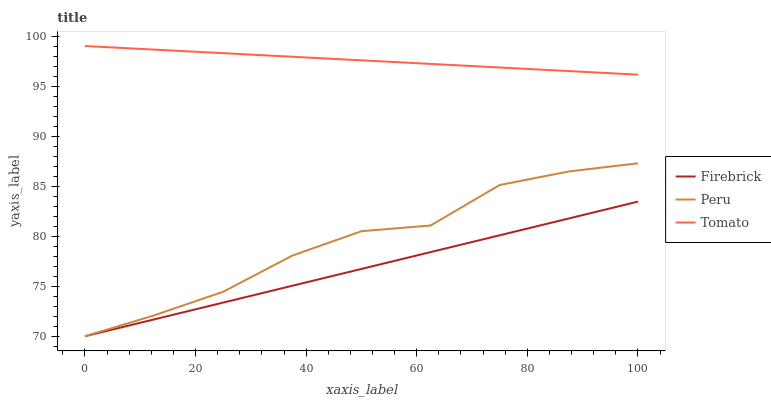Does Firebrick have the minimum area under the curve?
Answer yes or no. Yes. Does Tomato have the maximum area under the curve?
Answer yes or no. Yes. Does Peru have the minimum area under the curve?
Answer yes or no. No. Does Peru have the maximum area under the curve?
Answer yes or no. No. Is Tomato the smoothest?
Answer yes or no. Yes. Is Peru the roughest?
Answer yes or no. Yes. Is Firebrick the smoothest?
Answer yes or no. No. Is Firebrick the roughest?
Answer yes or no. No. Does Peru have the highest value?
Answer yes or no. No. Is Firebrick less than Tomato?
Answer yes or no. Yes. Is Tomato greater than Firebrick?
Answer yes or no. Yes. Does Firebrick intersect Tomato?
Answer yes or no. No. 